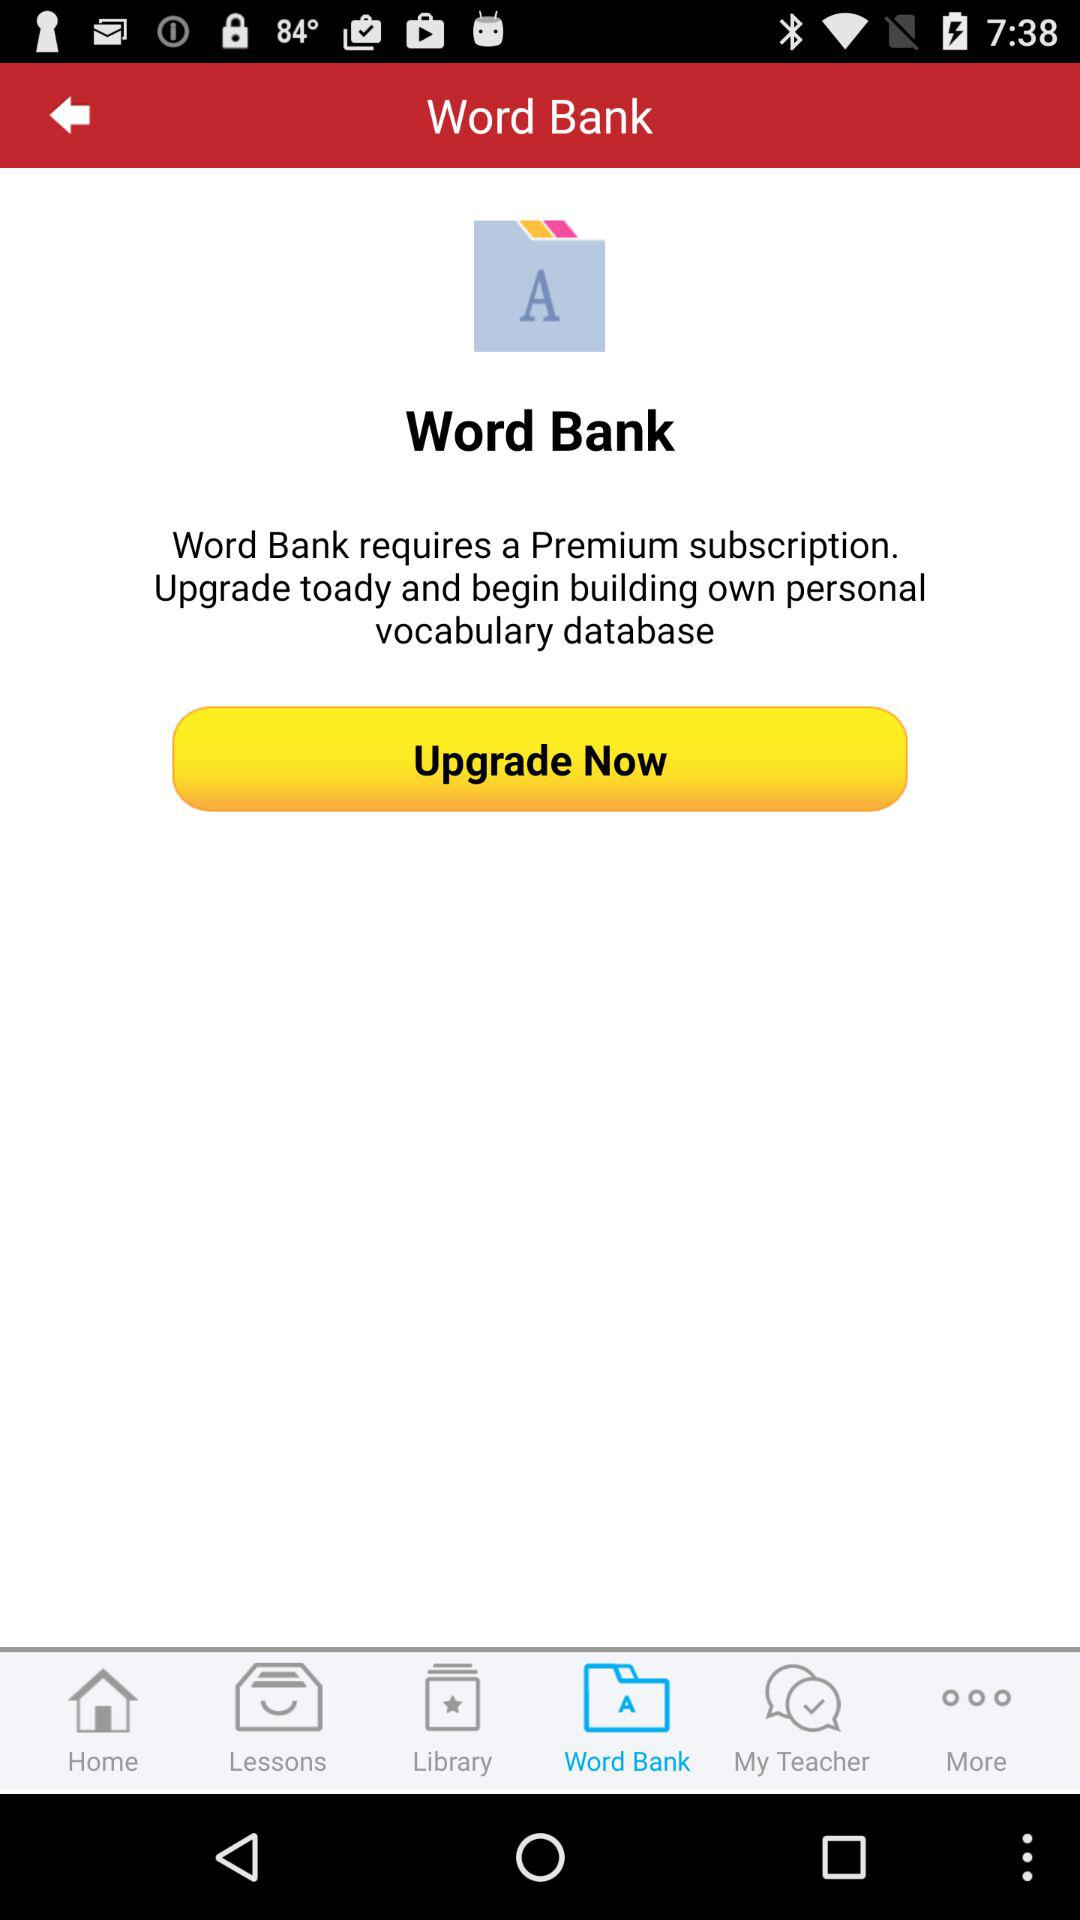Which tab is selected? The selected tab is "Word Bank". 